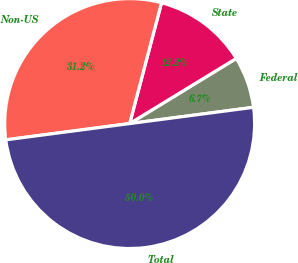<chart> <loc_0><loc_0><loc_500><loc_500><pie_chart><fcel>Federal<fcel>State<fcel>Non-US<fcel>Total<nl><fcel>6.65%<fcel>12.17%<fcel>31.18%<fcel>50.0%<nl></chart> 